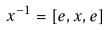<formula> <loc_0><loc_0><loc_500><loc_500>x ^ { - 1 } = [ e , x , e ]</formula> 